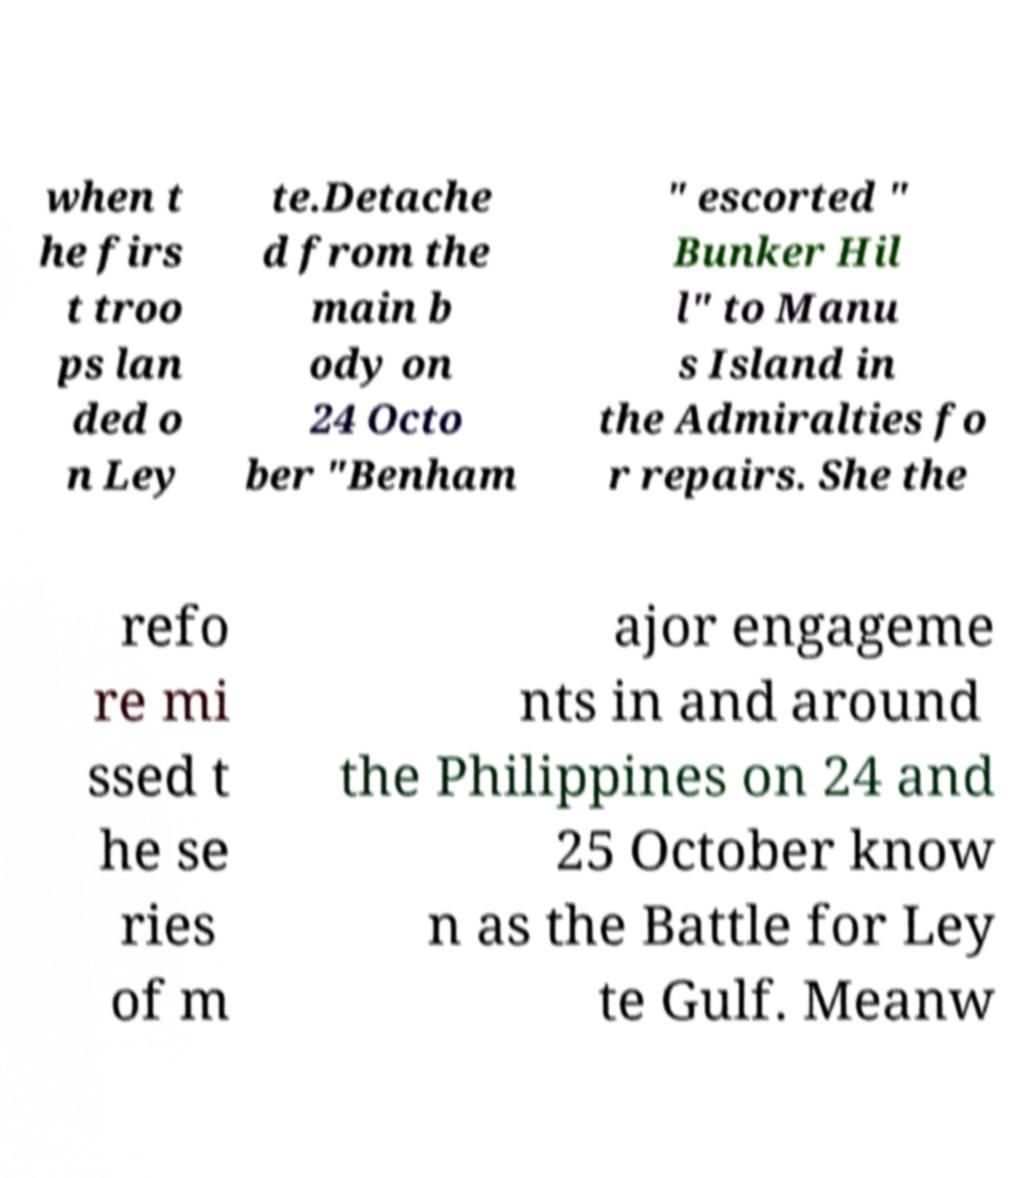There's text embedded in this image that I need extracted. Can you transcribe it verbatim? when t he firs t troo ps lan ded o n Ley te.Detache d from the main b ody on 24 Octo ber "Benham " escorted " Bunker Hil l" to Manu s Island in the Admiralties fo r repairs. She the refo re mi ssed t he se ries of m ajor engageme nts in and around the Philippines on 24 and 25 October know n as the Battle for Ley te Gulf. Meanw 